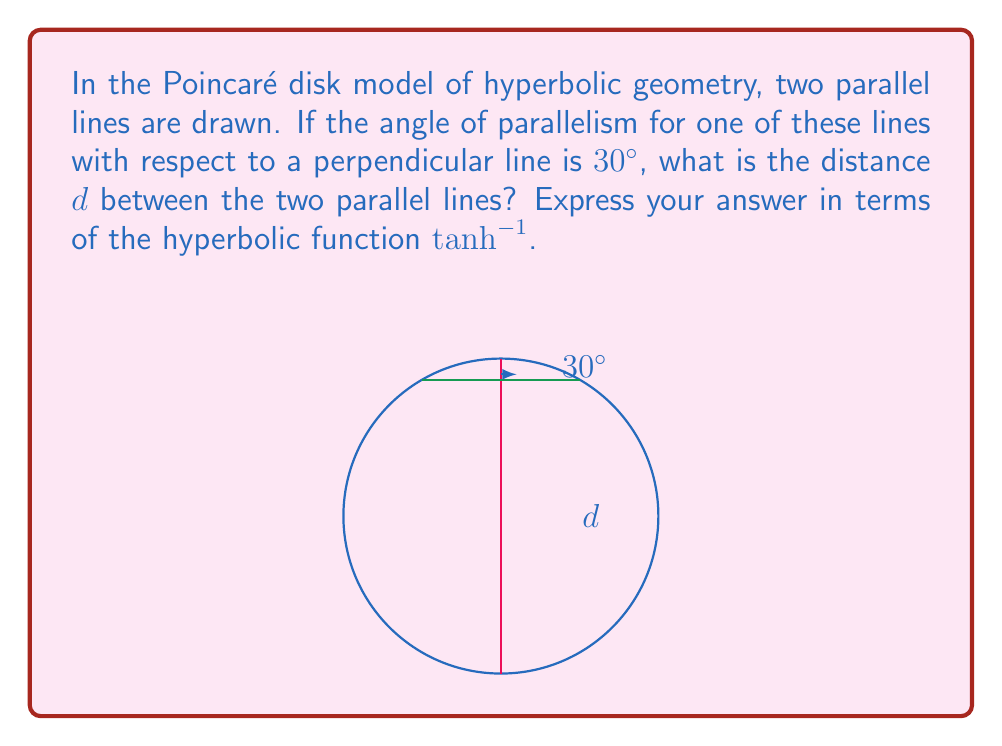Can you solve this math problem? Let's approach this step-by-step:

1) In hyperbolic geometry, the angle of parallelism $\alpha$ is related to the distance $x$ from a point to a line by the formula:

   $$\tan(\frac{\alpha}{2}) = e^{-x}$$

2) We're given that $\alpha = 30°$. Let's substitute this into the formula:

   $$\tan(15°) = e^{-x}$$

3) Now, let's solve for $x$:

   $$x = -\ln(\tan(15°))$$

4) This distance $x$ represents half of the total distance $d$ between the two parallel lines. So:

   $$d = 2x = -2\ln(\tan(15°))$$

5) We can simplify this further. Recall that:

   $$\tanh^{-1}(y) = \frac{1}{2}\ln(\frac{1+y}{1-y})$$

6) If we let $y = \cos(30°) = \frac{\sqrt{3}}{2}$, then:

   $$\tanh^{-1}(\frac{\sqrt{3}}{2}) = \frac{1}{2}\ln(\frac{1+\frac{\sqrt{3}}{2}}{1-\frac{\sqrt{3}}{2}}) = \frac{1}{2}\ln(\frac{2+\sqrt{3}}{2-\sqrt{3}}) = -\ln(\tan(15°))$$

7) Therefore, we can express $d$ as:

   $$d = 2\tanh^{-1}(\frac{\sqrt{3}}{2})$$

This is the distance between the two parallel lines in the Poincaré disk model.
Answer: $d = 2\tanh^{-1}(\frac{\sqrt{3}}{2})$ 